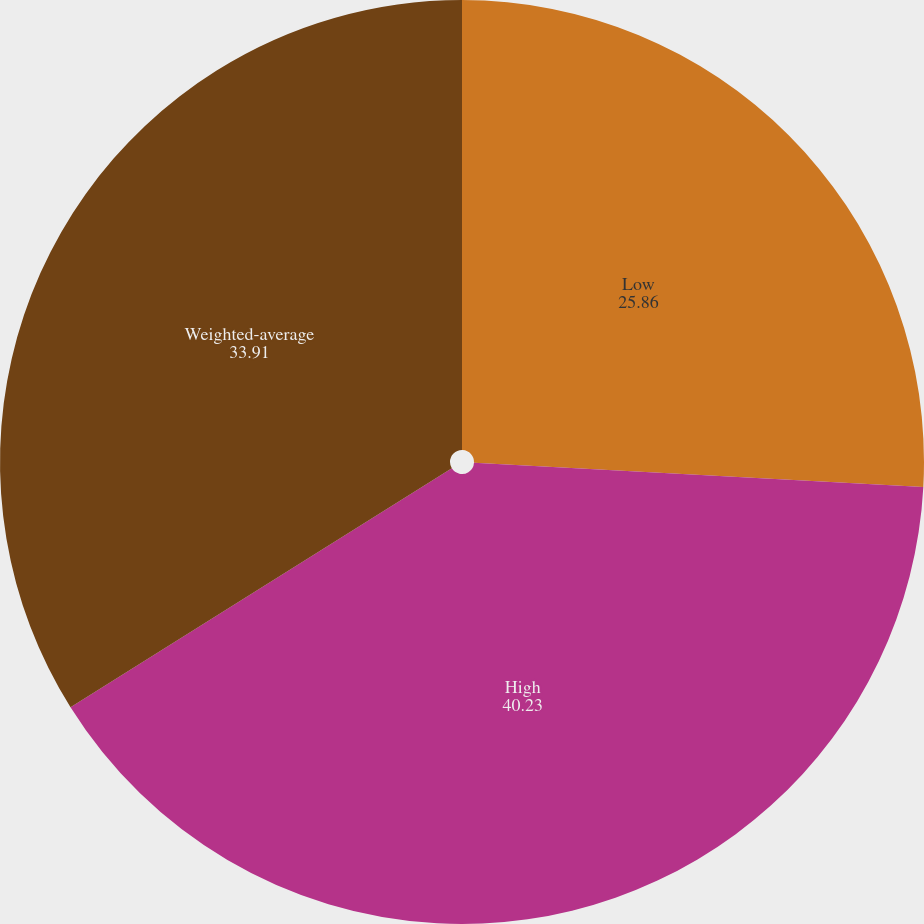Convert chart to OTSL. <chart><loc_0><loc_0><loc_500><loc_500><pie_chart><fcel>Low<fcel>High<fcel>Weighted-average<nl><fcel>25.86%<fcel>40.23%<fcel>33.91%<nl></chart> 